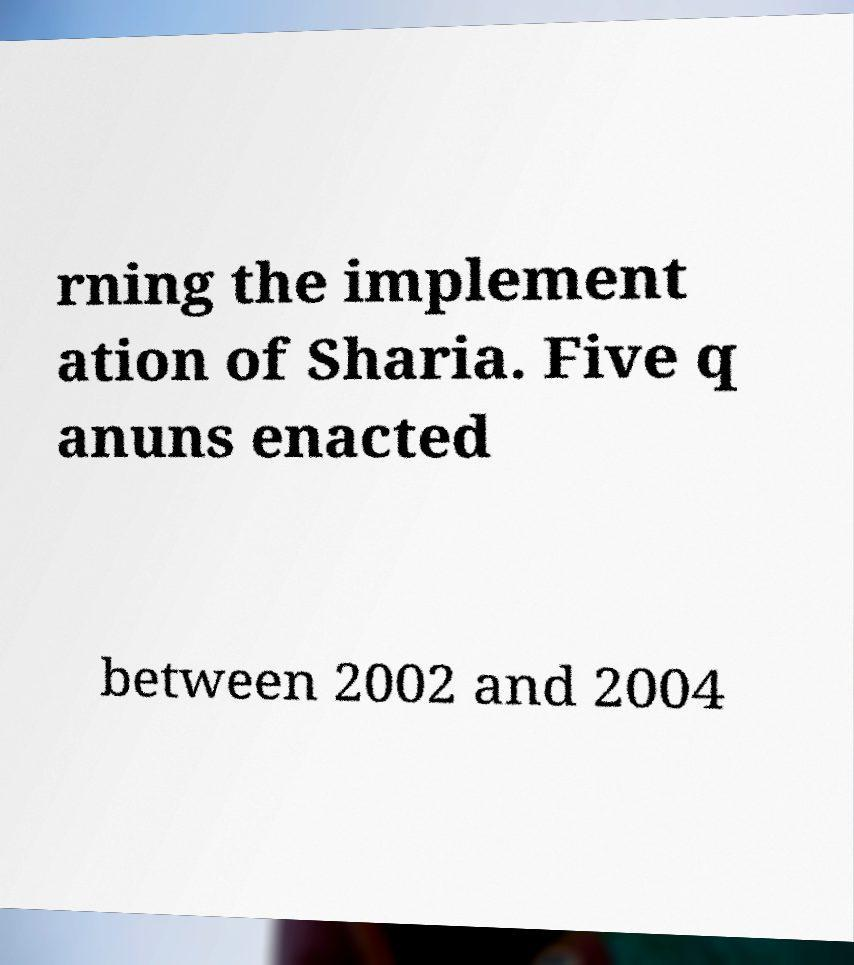Please identify and transcribe the text found in this image. rning the implement ation of Sharia. Five q anuns enacted between 2002 and 2004 